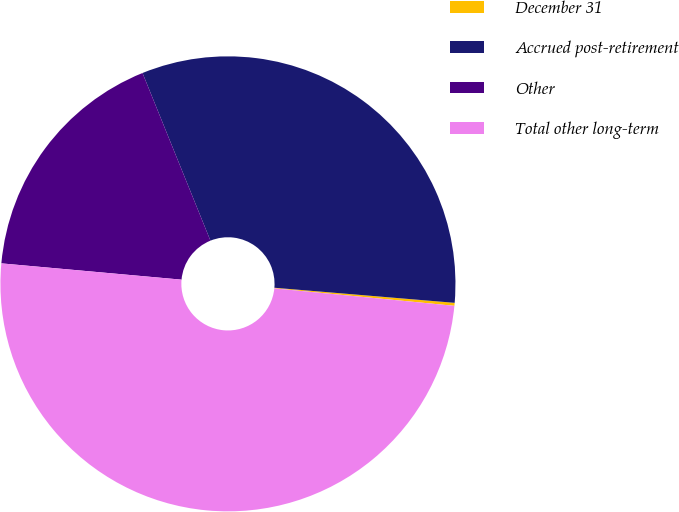<chart> <loc_0><loc_0><loc_500><loc_500><pie_chart><fcel>December 31<fcel>Accrued post-retirement<fcel>Other<fcel>Total other long-term<nl><fcel>0.21%<fcel>32.46%<fcel>17.44%<fcel>49.9%<nl></chart> 